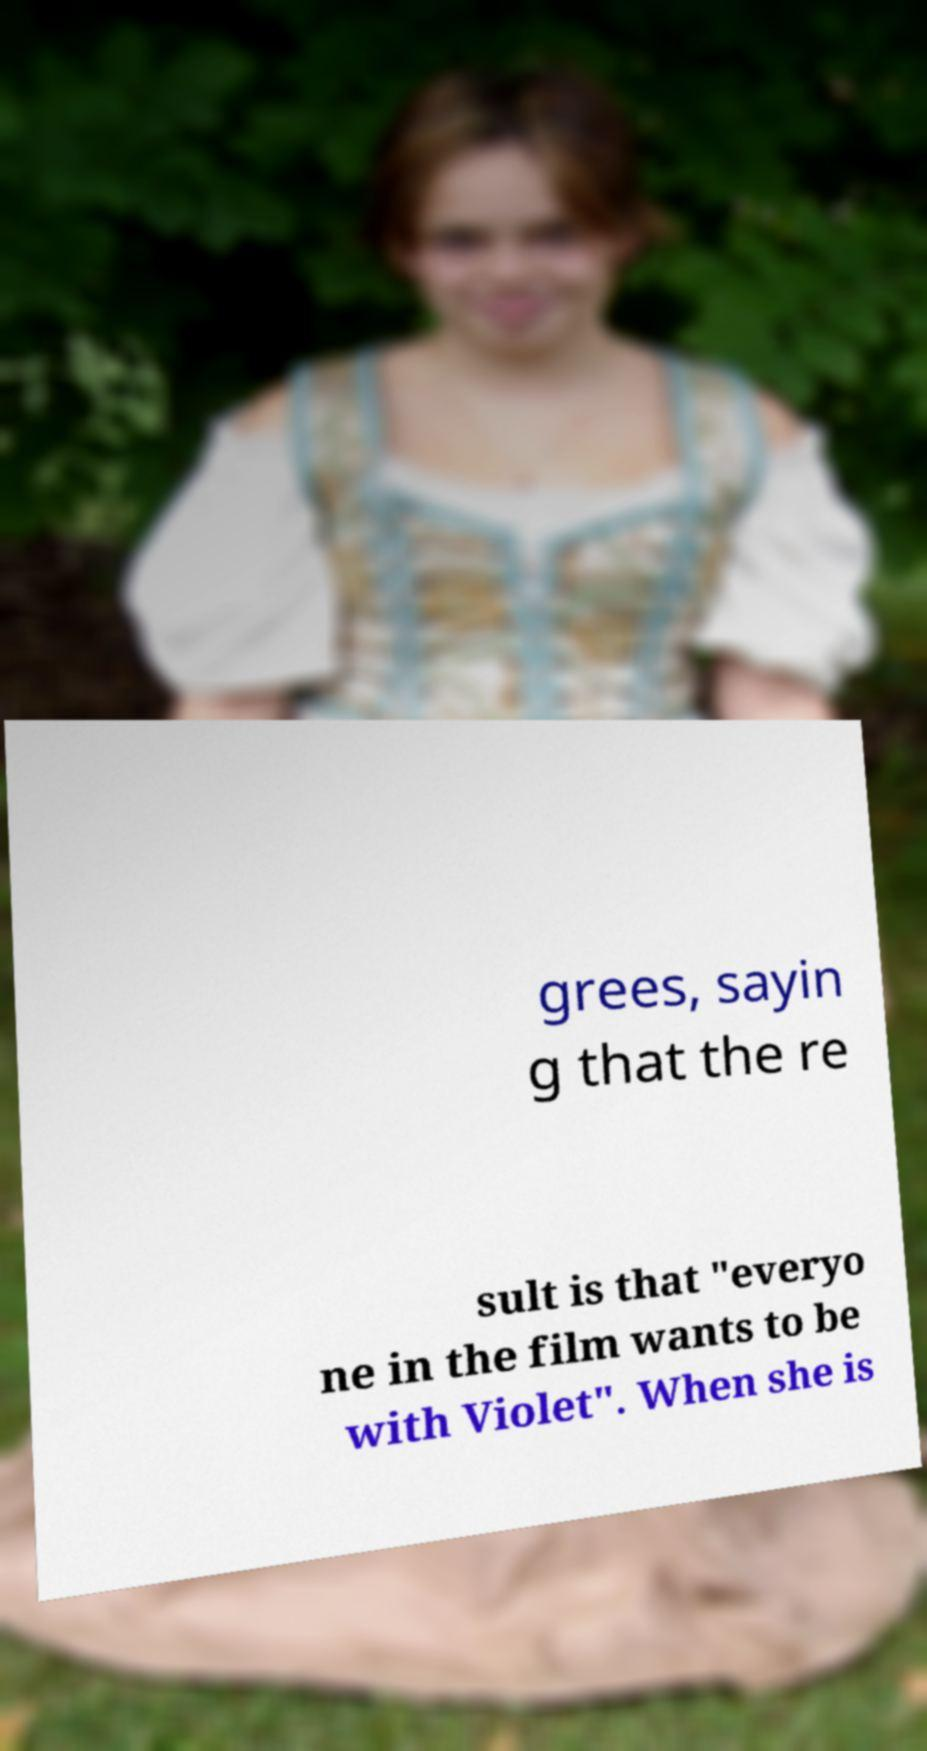For documentation purposes, I need the text within this image transcribed. Could you provide that? grees, sayin g that the re sult is that "everyo ne in the film wants to be with Violet". When she is 